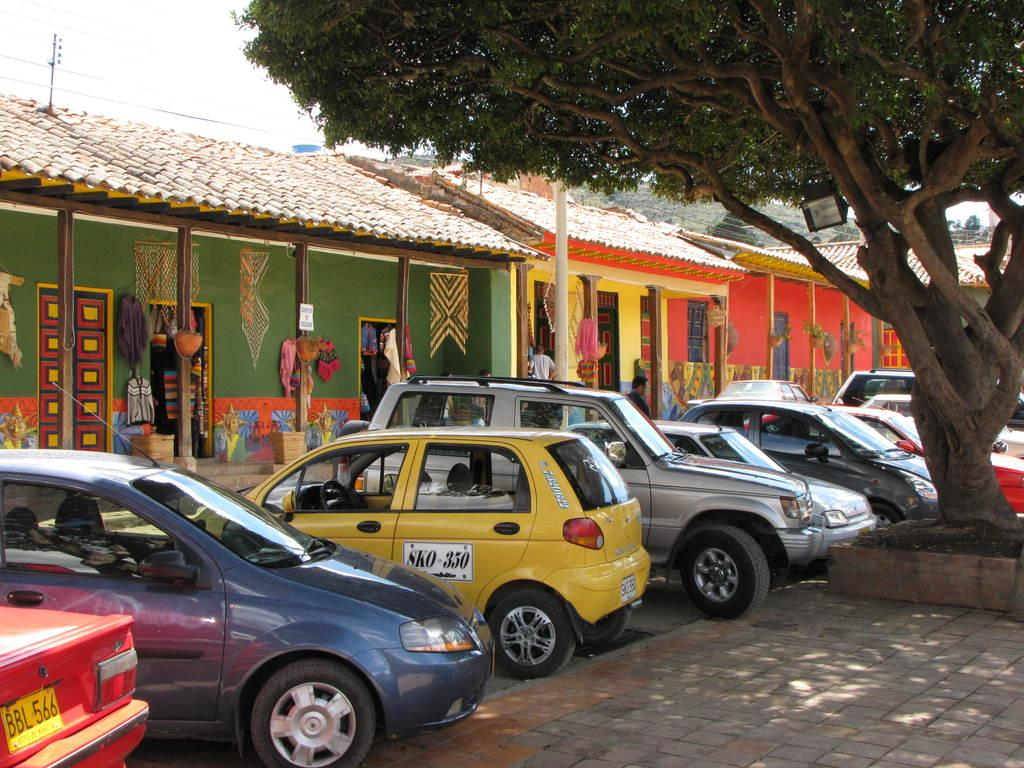<image>
Create a compact narrative representing the image presented. The license plate on the left-most car reads BBL 566. 